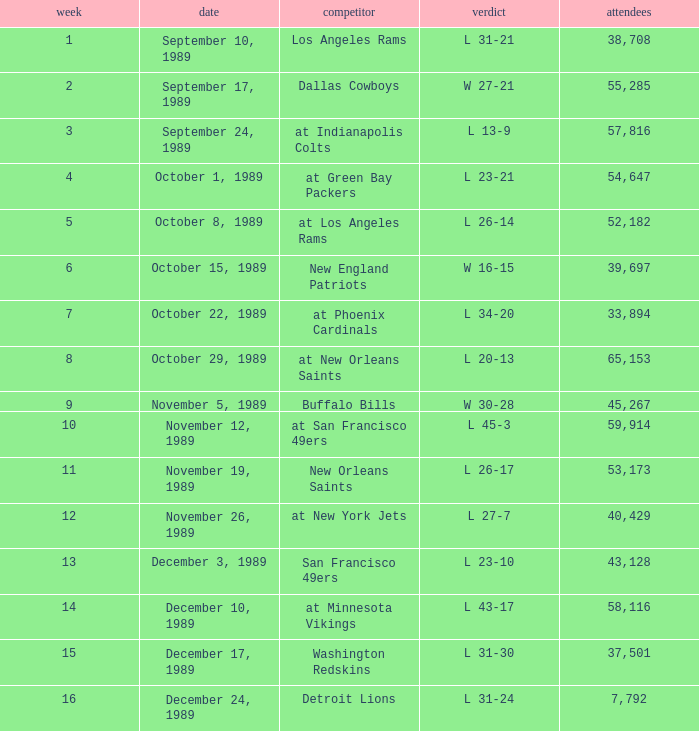For what week was the attendance 40,429? 12.0. 